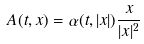<formula> <loc_0><loc_0><loc_500><loc_500>A ( t , x ) = \alpha ( t , | x | ) \frac { x } { | x | ^ { 2 } }</formula> 